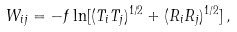<formula> <loc_0><loc_0><loc_500><loc_500>W _ { i j } = - f \ln [ ( T _ { i } T _ { j } ) ^ { 1 / 2 } + ( R _ { i } R _ { j } ) ^ { 1 / 2 } ] \, ,</formula> 